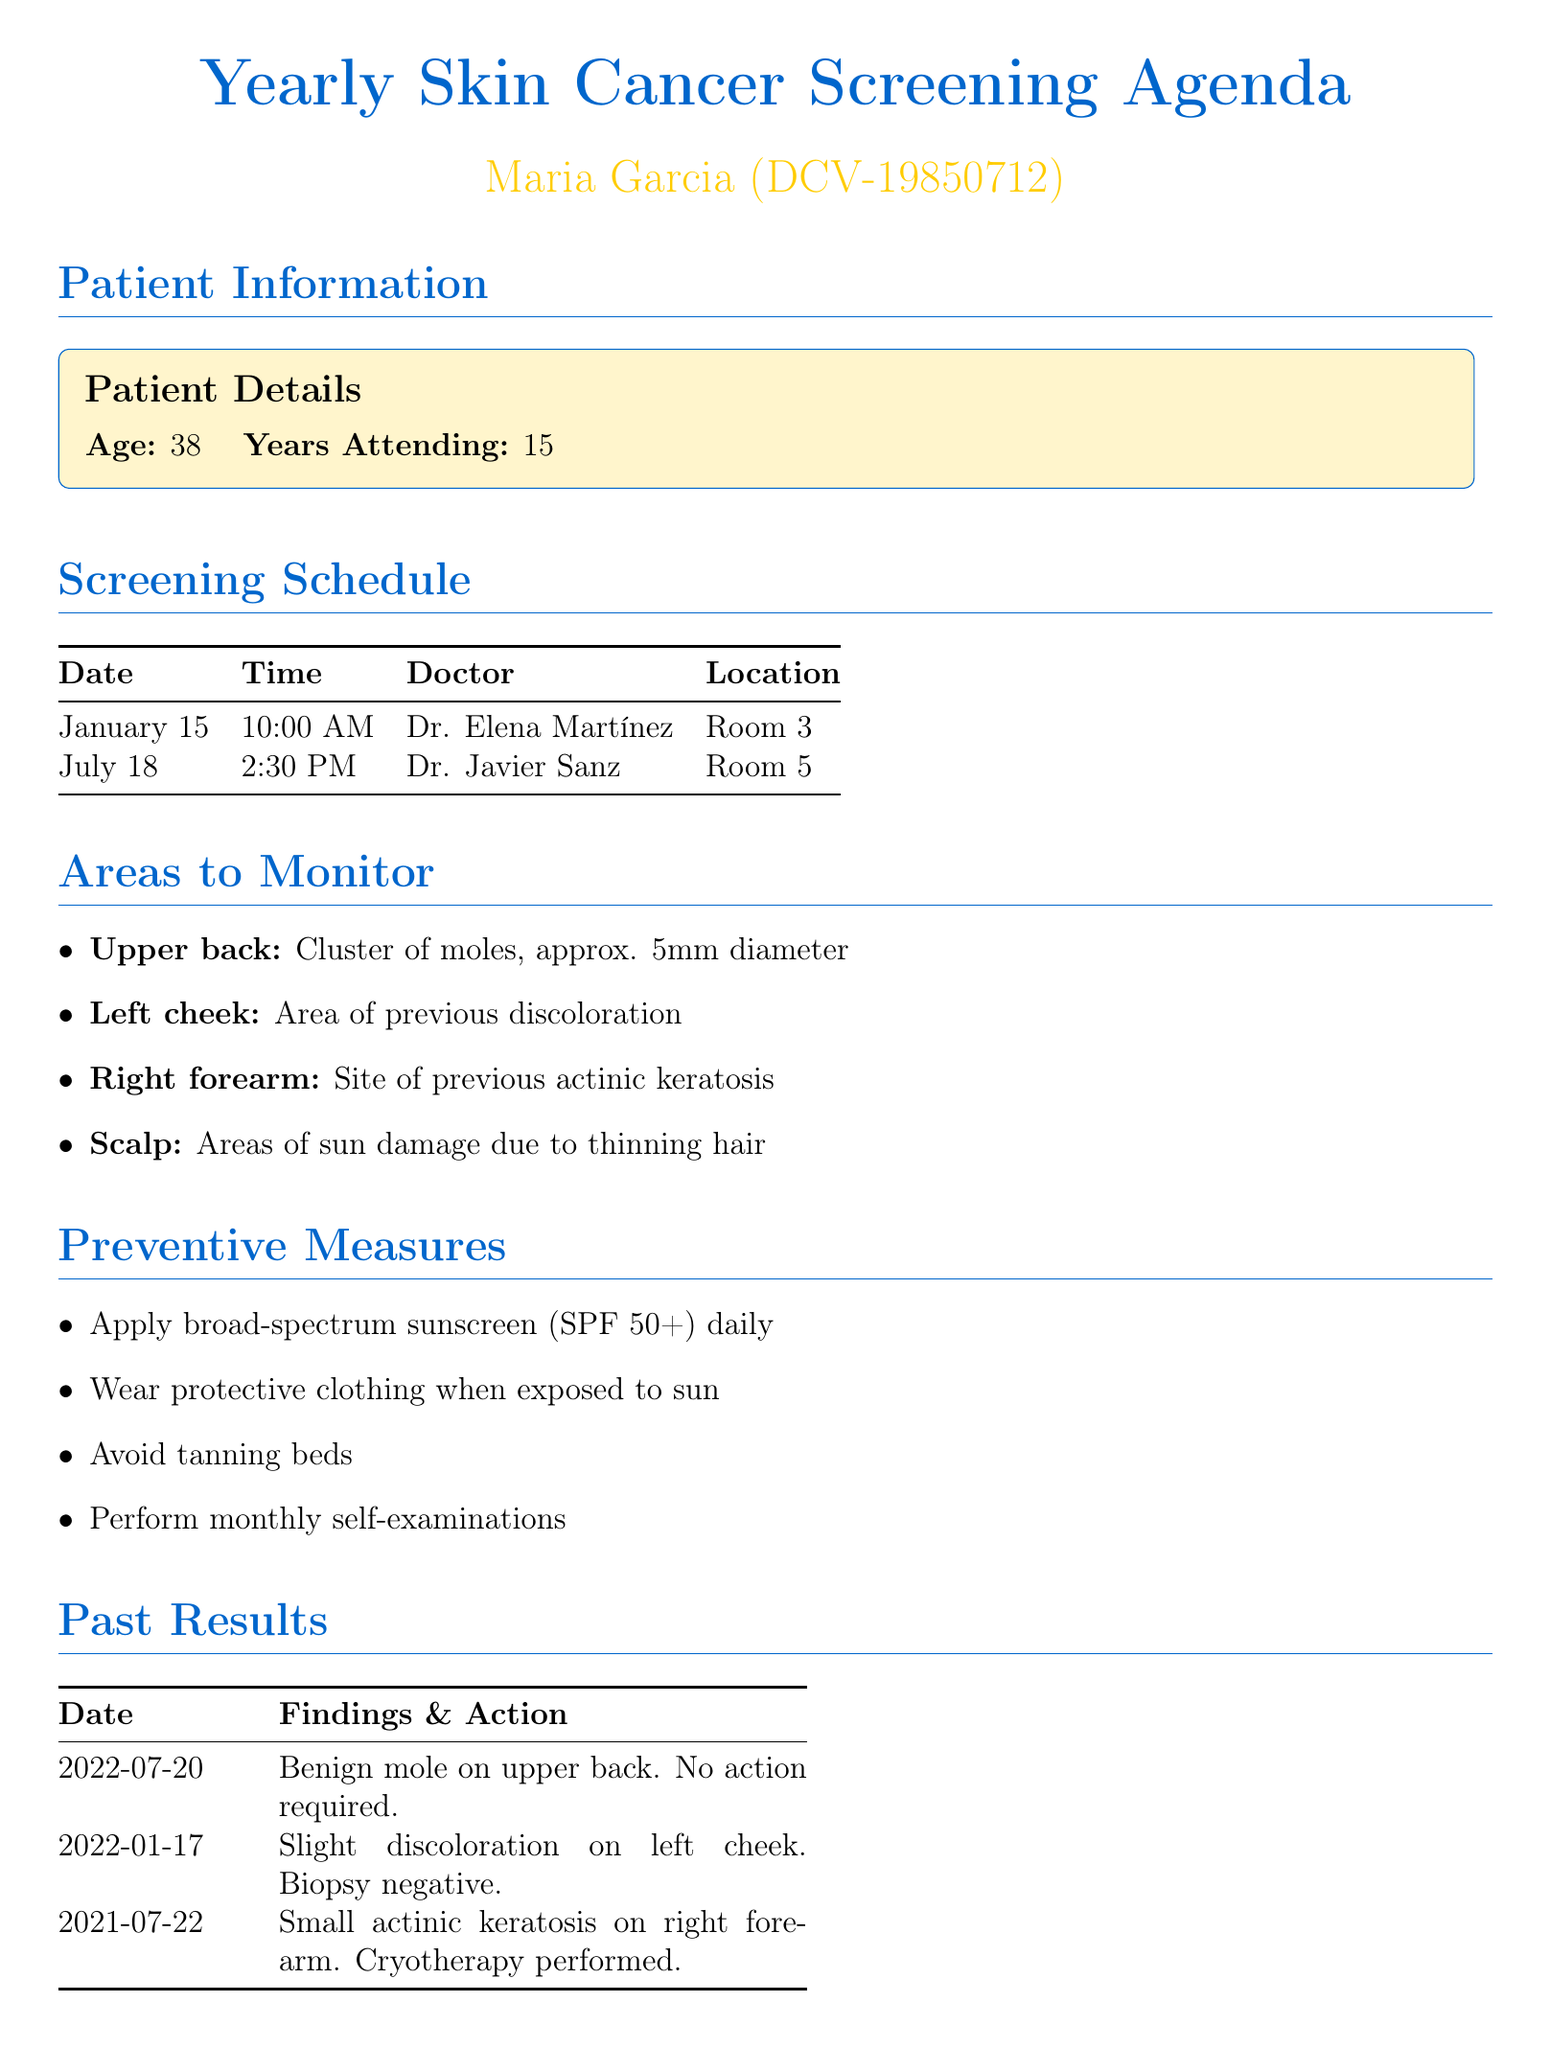What is the name of the doctor for the January screening? The January screening is scheduled with Dr. Elena Martínez.
Answer: Dr. Elena Martínez What is the time of the July appointment? The July appointment is set for 2:30 PM.
Answer: 2:30 PM What were the findings from the screening on July 20, 2022? The findings on July 20, 2022, were a benign mole on the upper back.
Answer: Benign mole on upper back What action was taken for the left cheek during the January 17, 2022 screening? A biopsy was performed for the left cheek on January 17, 2022.
Answer: Biopsy performed How many areas are listed to monitor? There are four areas listed to monitor in the document.
Answer: Four What should be applied daily for sun protection? Broad-spectrum sunscreen should be applied daily for sun protection.
Answer: Broad-spectrum sunscreen What type of clothing should be worn when exposed to the sun? Protective clothing should be worn when exposed to the sun.
Answer: Protective clothing What is the skin type of the patient? The patient has Fitzpatrick skin type III.
Answer: Fitzpatrick skin type III What is recommended for the scalp due to sun damage? Regular use of sunscreen and protective headwear is recommended for the scalp.
Answer: Regular use of sunscreen and protective headwear 